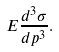<formula> <loc_0><loc_0><loc_500><loc_500>E \frac { d ^ { 3 } \sigma } { d p ^ { 3 } } .</formula> 